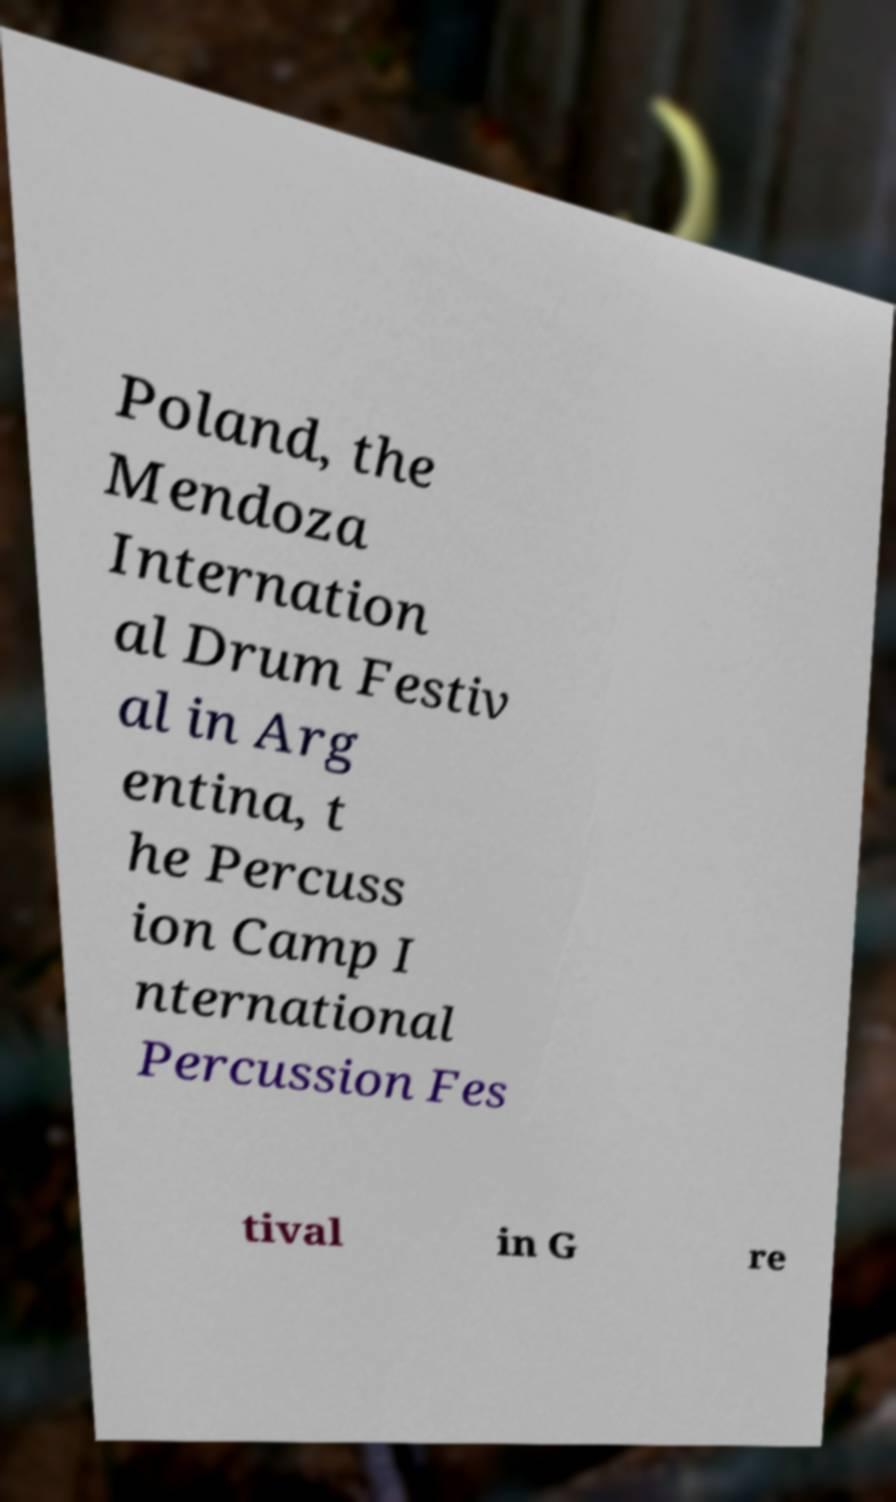Could you assist in decoding the text presented in this image and type it out clearly? Poland, the Mendoza Internation al Drum Festiv al in Arg entina, t he Percuss ion Camp I nternational Percussion Fes tival in G re 